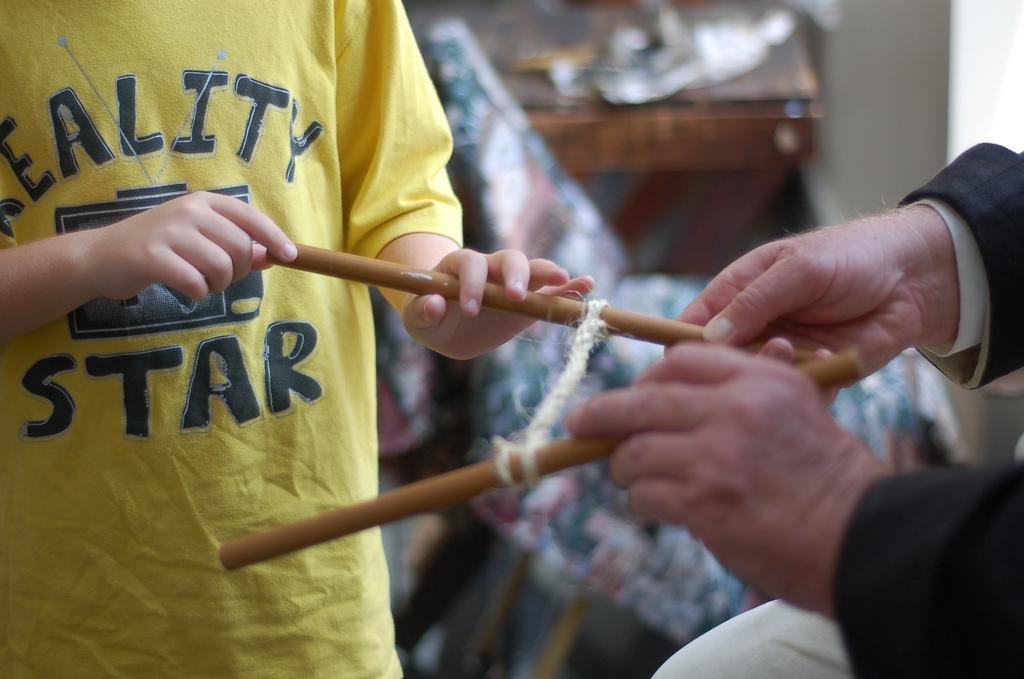Describe this image in one or two sentences. In this image I can see two people with yellow, black and white color dresses. I can see these people are holding the sticks. In the background I can see the chair, table and the wall. But the background is blurry. 